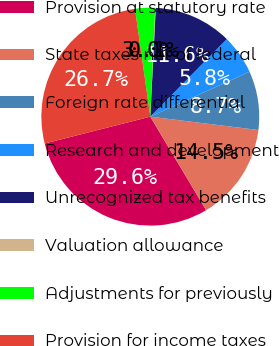Convert chart. <chart><loc_0><loc_0><loc_500><loc_500><pie_chart><fcel>Provision at statutory rate<fcel>State taxes net of federal<fcel>Foreign rate differential<fcel>Research and development<fcel>Unrecognized tax benefits<fcel>Valuation allowance<fcel>Adjustments for previously<fcel>Provision for income taxes<nl><fcel>29.6%<fcel>14.48%<fcel>8.72%<fcel>5.84%<fcel>11.6%<fcel>0.08%<fcel>2.96%<fcel>26.72%<nl></chart> 